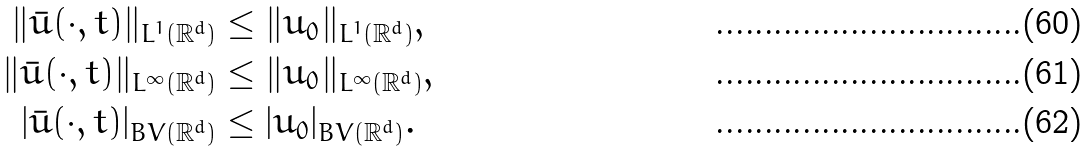<formula> <loc_0><loc_0><loc_500><loc_500>\| \bar { u } ( \cdot , t ) \| _ { L ^ { 1 } ( \mathbb { R } ^ { d } ) } & \leq \| u _ { 0 } \| _ { L ^ { 1 } ( \mathbb { R } ^ { d } ) } , \\ \| \bar { u } ( \cdot , t ) \| _ { L ^ { \infty } ( \mathbb { R } ^ { d } ) } & \leq \| u _ { 0 } \| _ { L ^ { \infty } ( \mathbb { R } ^ { d } ) } , \\ | \bar { u } ( \cdot , t ) | _ { B V ( \mathbb { R } ^ { d } ) } & \leq | u _ { 0 } | _ { B V ( \mathbb { R } ^ { d } ) } .</formula> 